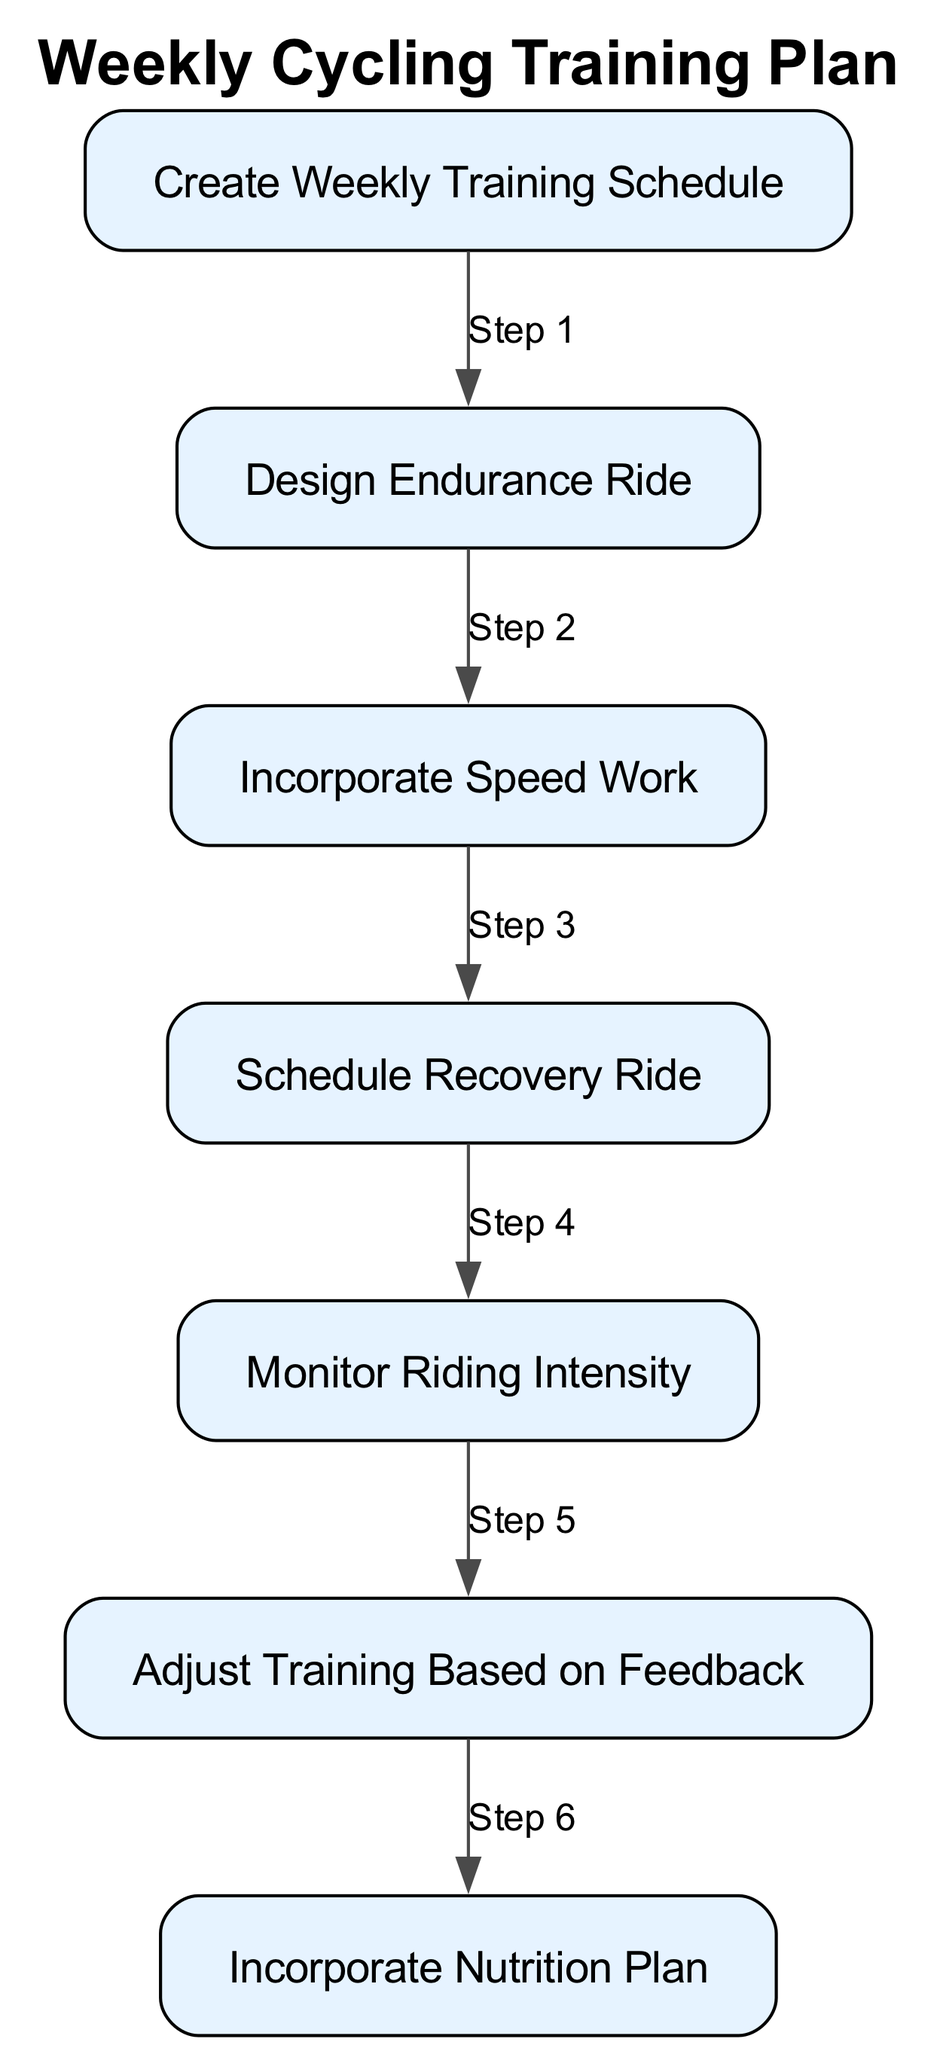What is the first step in the training schedule? The diagram illustrates that the first step is to "Create Weekly Training Schedule," which defines the outline of rides for the week.
Answer: Create Weekly Training Schedule How many types of rides are included in the diagram? The diagram outlines five distinct types of activities: create a weekly schedule, endurance ride, speed work, recovery ride, and adjust training based on feedback.
Answer: Five What follows after "Incorporate Nutrition Plan"? The flow of the diagram indicates that "Incorporate Nutrition Plan" is the last step, so there is no subsequent step after it.
Answer: None Which step involves high-intensity intervals? The step "Incorporate Speed Work" specifically mentions including intervals of high-intensity riding aimed at improving speed and power.
Answer: Incorporate Speed Work What type of ride is assigned as easy and low-intensity? The step "Schedule Recovery Ride" focuses on assigning easy rides to promote recovery and prevent fatigue, which matches the description.
Answer: Schedule Recovery Ride How many edges connect the nodes in total? Counting the connections, there are six edges linking the seven nodes together according to the sequence defined in the diagram.
Answer: Six Which step comes before "Adjust Training Based on Feedback"? In the sequence of the diagram, "Monitor Riding Intensity" occurs immediately before the step regarding adjusting training based on performance feedback.
Answer: Monitor Riding Intensity What is the purpose of "Design Endurance Ride"? This step is aimed at planning a long ride that maintains a steady pace, contributing to the development of stamina.
Answer: To build stamina Which step emphasizes the use of a heart rate monitor? The step titled "Monitor Riding Intensity" emphasizes using a heart rate monitor to ensure that rides are performed within the intended intensity zones.
Answer: Monitor Riding Intensity 